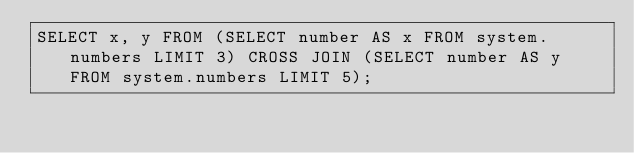Convert code to text. <code><loc_0><loc_0><loc_500><loc_500><_SQL_>SELECT x, y FROM (SELECT number AS x FROM system.numbers LIMIT 3) CROSS JOIN (SELECT number AS y FROM system.numbers LIMIT 5);
</code> 